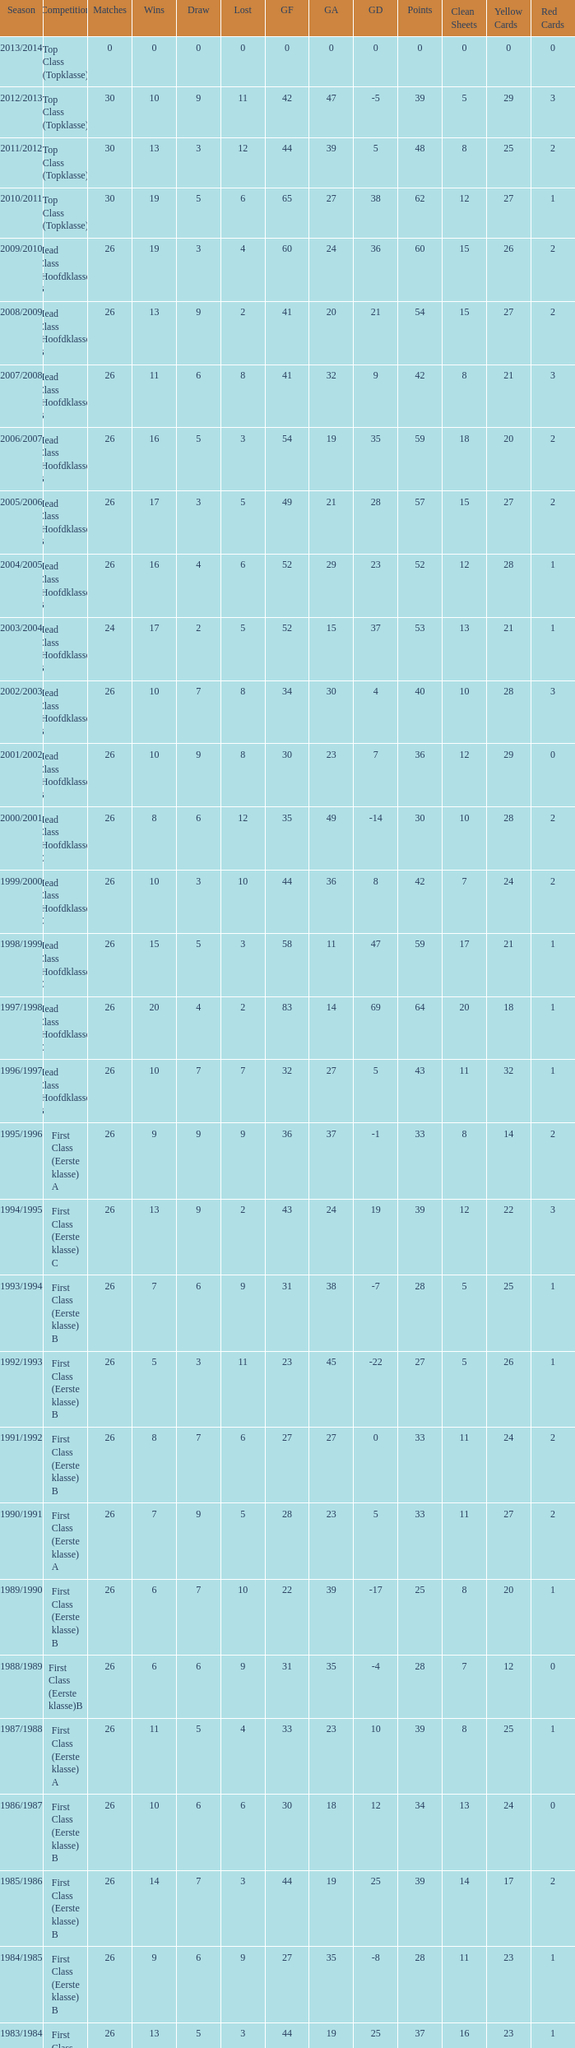What is the sum of the losses that a match score larger than 26, a points score of 62, and a draw greater than 5? None. 